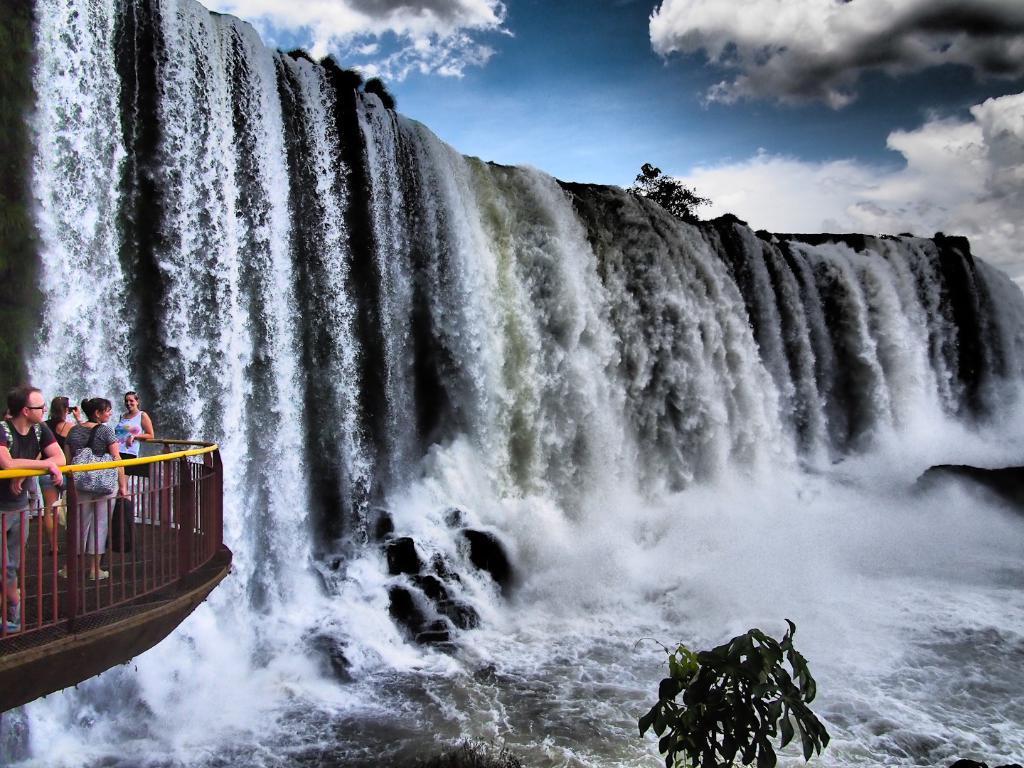Describe this image in one or two sentences. There is a waterfall and beside the waterfall there is a bridge and inside the bridge the tourist are enjoying the beautiful view. 